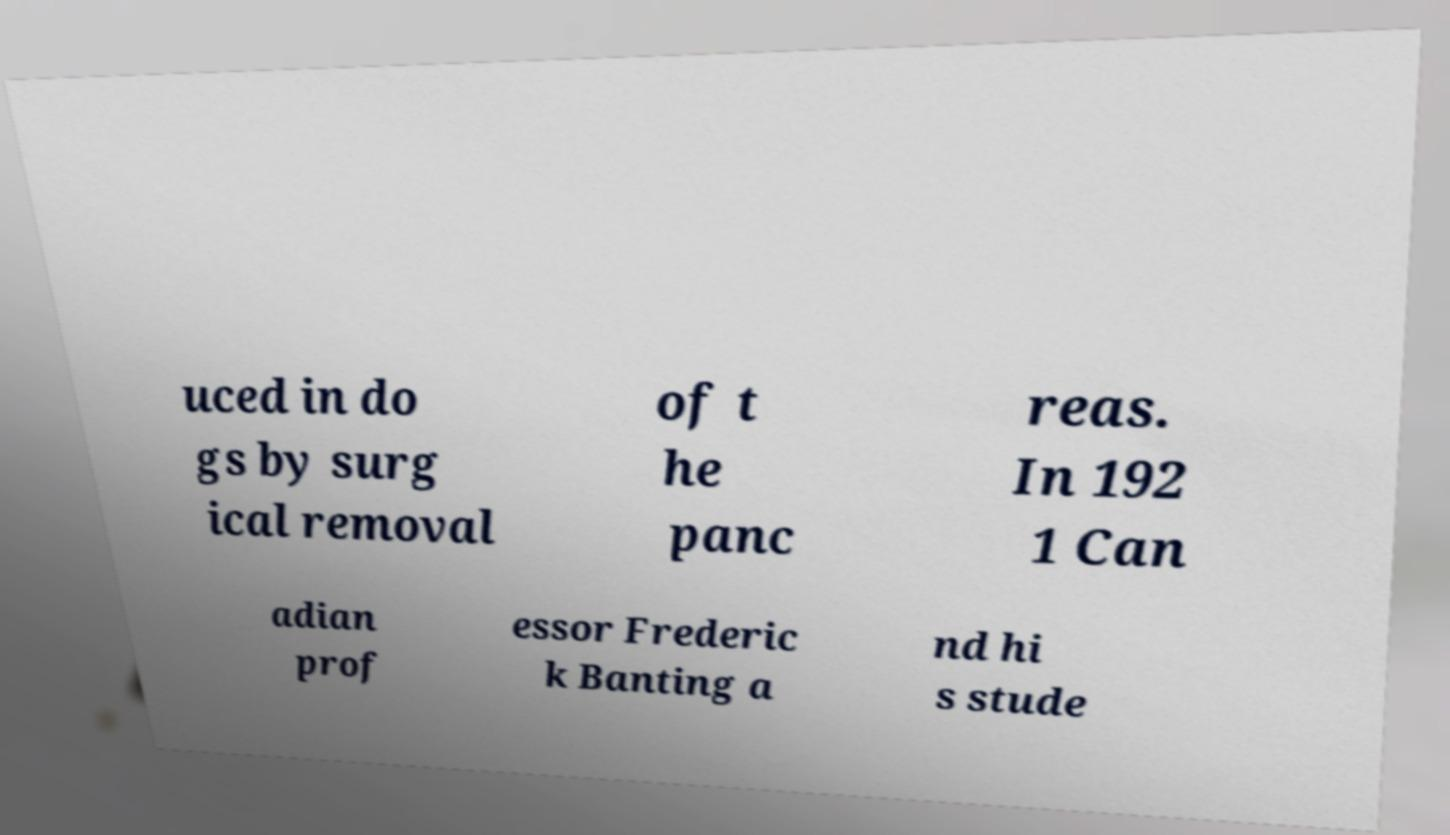Could you extract and type out the text from this image? uced in do gs by surg ical removal of t he panc reas. In 192 1 Can adian prof essor Frederic k Banting a nd hi s stude 